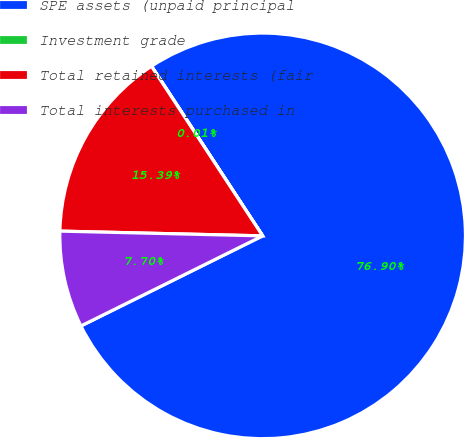Convert chart to OTSL. <chart><loc_0><loc_0><loc_500><loc_500><pie_chart><fcel>SPE assets (unpaid principal<fcel>Investment grade<fcel>Total retained interests (fair<fcel>Total interests purchased in<nl><fcel>76.9%<fcel>0.01%<fcel>15.39%<fcel>7.7%<nl></chart> 